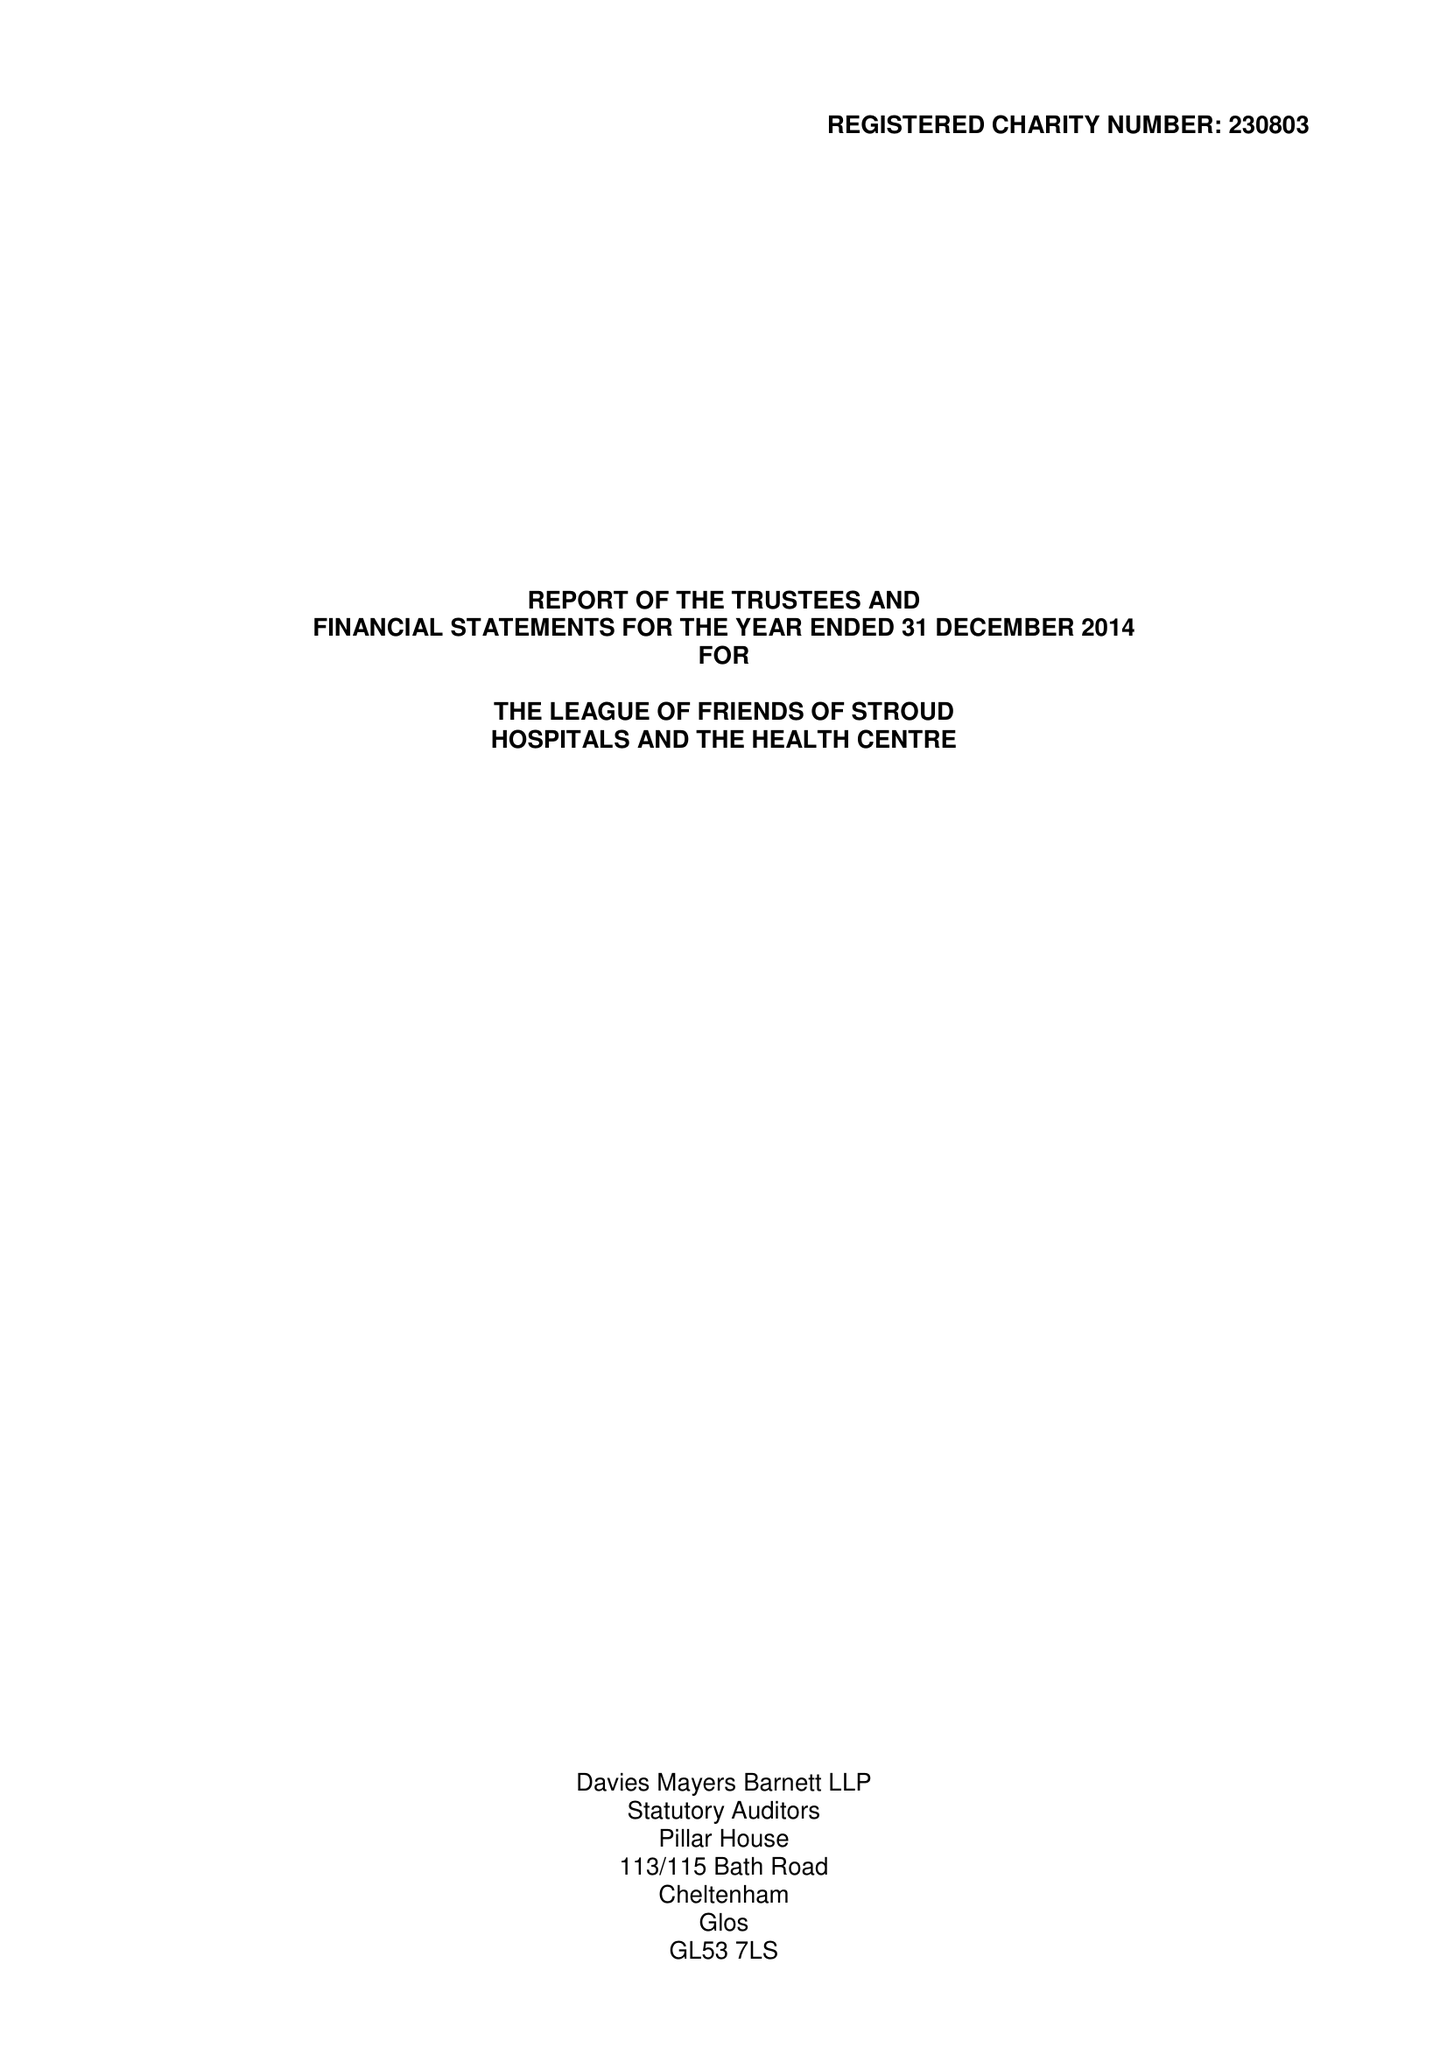What is the value for the report_date?
Answer the question using a single word or phrase. 2014-12-31 